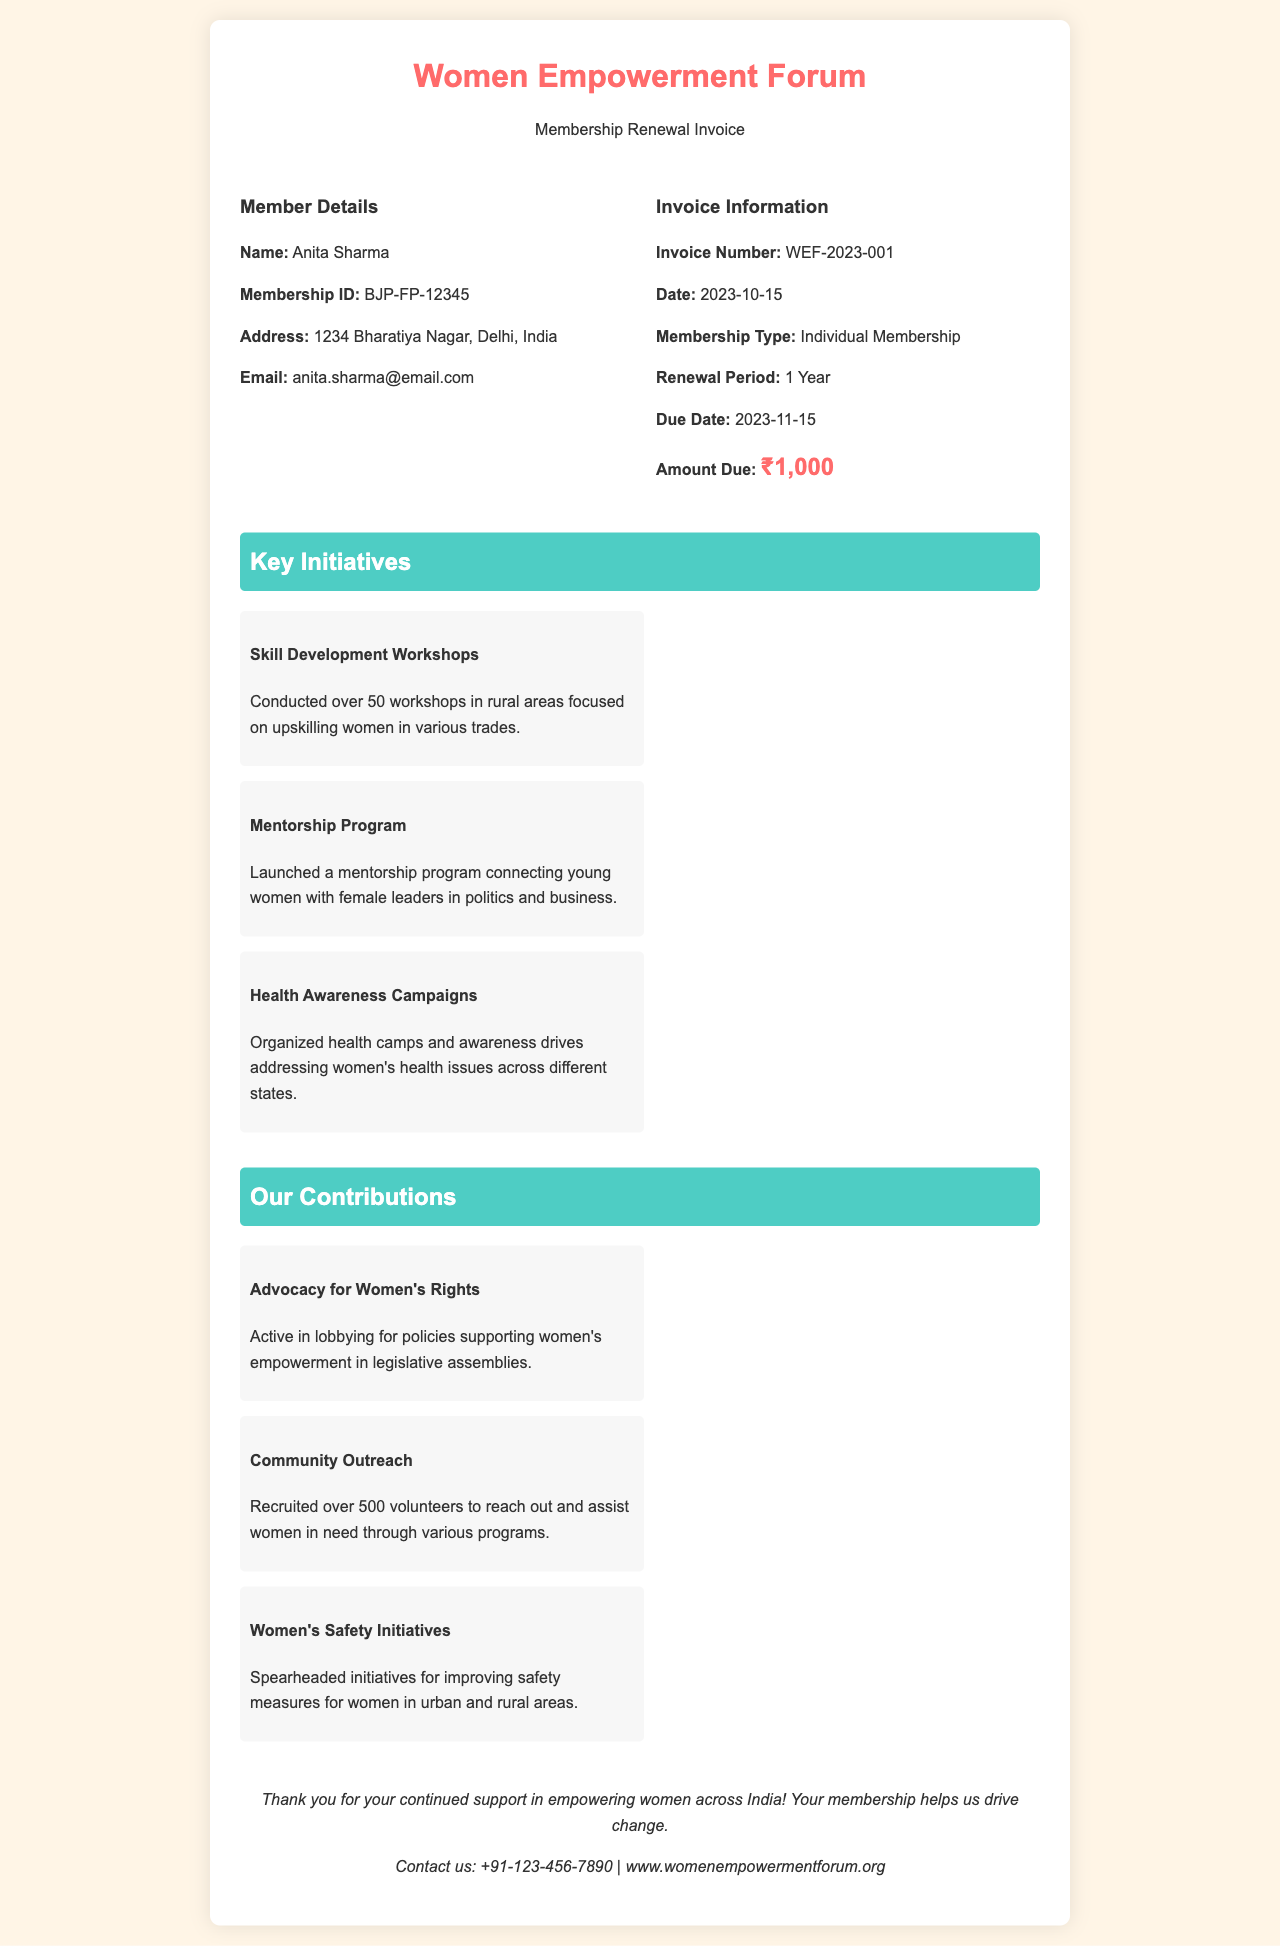What is the name of the member? The document provides the member's name as "Anita Sharma."
Answer: Anita Sharma What is the membership ID? The membership ID is specified in the document as "BJP-FP-12345."
Answer: BJP-FP-12345 What is the amount due for renewal? The invoice clearly states that the amount due is "₹1,000."
Answer: ₹1,000 When is the due date for the membership renewal? The document lists the due date as "2023-11-15."
Answer: 2023-11-15 What is one of the key initiatives mentioned? The document includes several key initiatives, for example, "Skill Development Workshops."
Answer: Skill Development Workshops How many workshops were conducted in the skill development initiative? It states that over "50 workshops" were conducted in rural areas.
Answer: 50 workshops What is one of the contributions related to women's safety? The document mentions the contribution as "Women's Safety Initiatives."
Answer: Women's Safety Initiatives What is the contact number provided at the end of the document? The contact number for the organization is "+91-123-456-7890."
Answer: +91-123-456-7890 What type of membership is being renewed? The membership type specified in the document is "Individual Membership."
Answer: Individual Membership 